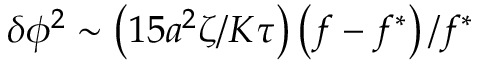Convert formula to latex. <formula><loc_0><loc_0><loc_500><loc_500>\delta \phi ^ { 2 } \sim \left ( 1 5 a ^ { 2 } \zeta / K \tau \right ) \left ( f - f ^ { \ast } \right ) / f ^ { \ast }</formula> 